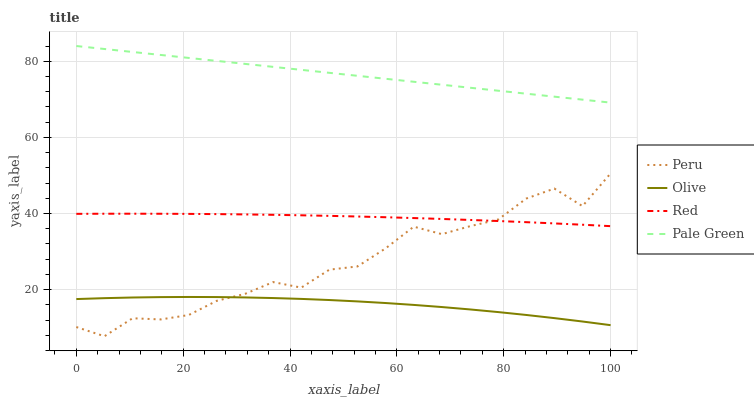Does Olive have the minimum area under the curve?
Answer yes or no. Yes. Does Pale Green have the maximum area under the curve?
Answer yes or no. Yes. Does Red have the minimum area under the curve?
Answer yes or no. No. Does Red have the maximum area under the curve?
Answer yes or no. No. Is Pale Green the smoothest?
Answer yes or no. Yes. Is Peru the roughest?
Answer yes or no. Yes. Is Red the smoothest?
Answer yes or no. No. Is Red the roughest?
Answer yes or no. No. Does Peru have the lowest value?
Answer yes or no. Yes. Does Red have the lowest value?
Answer yes or no. No. Does Pale Green have the highest value?
Answer yes or no. Yes. Does Red have the highest value?
Answer yes or no. No. Is Olive less than Pale Green?
Answer yes or no. Yes. Is Pale Green greater than Red?
Answer yes or no. Yes. Does Peru intersect Red?
Answer yes or no. Yes. Is Peru less than Red?
Answer yes or no. No. Is Peru greater than Red?
Answer yes or no. No. Does Olive intersect Pale Green?
Answer yes or no. No. 